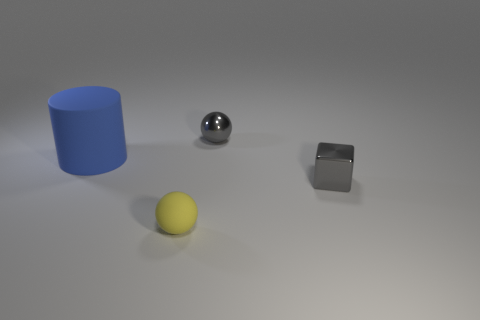Add 2 tiny blue metal blocks. How many objects exist? 6 Subtract all gray spheres. How many spheres are left? 1 Subtract all tiny yellow rubber objects. Subtract all big objects. How many objects are left? 2 Add 2 tiny yellow rubber things. How many tiny yellow rubber things are left? 3 Add 4 small blue matte spheres. How many small blue matte spheres exist? 4 Subtract 0 red spheres. How many objects are left? 4 Subtract all cyan cylinders. Subtract all brown cubes. How many cylinders are left? 1 